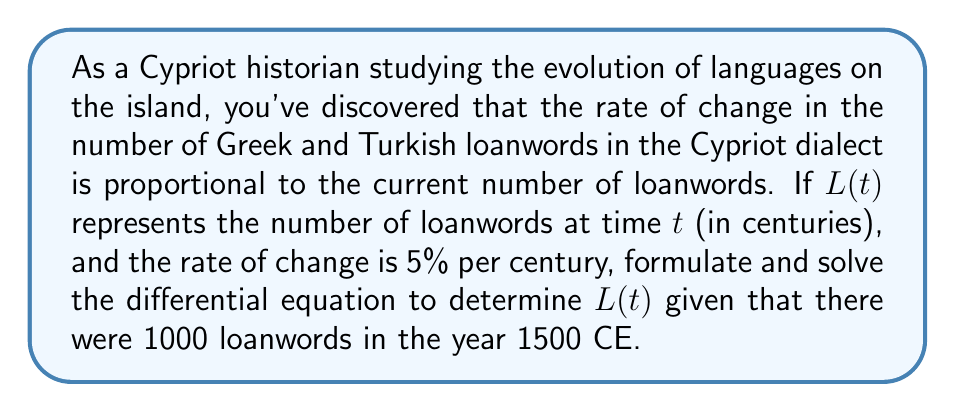Teach me how to tackle this problem. 1) First, we formulate the differential equation:
   The rate of change is proportional to the current number of loanwords:
   $$\frac{dL}{dt} = kL$$
   where $k$ is the proportionality constant.

2) We're given that the rate of change is 5% per century, so $k = 0.05$.
   The differential equation becomes:
   $$\frac{dL}{dt} = 0.05L$$

3) This is a separable first-order differential equation. We solve it as follows:
   $$\frac{dL}{L} = 0.05dt$$

4) Integrate both sides:
   $$\int \frac{dL}{L} = \int 0.05dt$$
   $$\ln|L| = 0.05t + C$$

5) Exponentiate both sides:
   $$L = e^{0.05t + C} = e^C \cdot e^{0.05t} = Ae^{0.05t}$$
   where $A = e^C$ is a constant.

6) Use the initial condition: In 1500 CE, $L(0) = 1000$ (we set $t=0$ at 1500 CE)
   $$1000 = Ae^{0.05 \cdot 0} = A$$

7) Therefore, the solution is:
   $$L(t) = 1000e^{0.05t}$$
   where $t$ is measured in centuries from 1500 CE.
Answer: $L(t) = 1000e^{0.05t}$ 